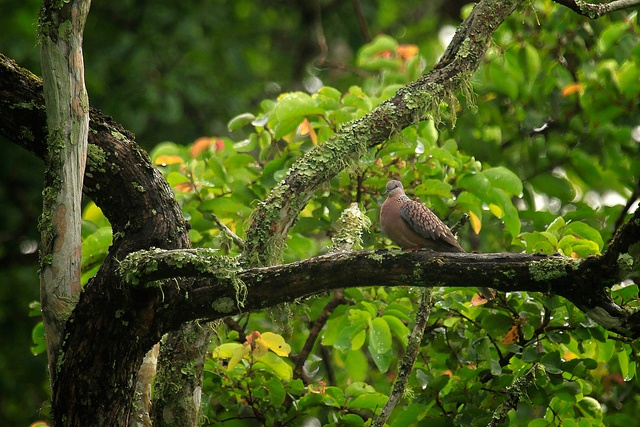Describe the objects in this image and their specific colors. I can see a bird in darkgreen, black, and gray tones in this image. 